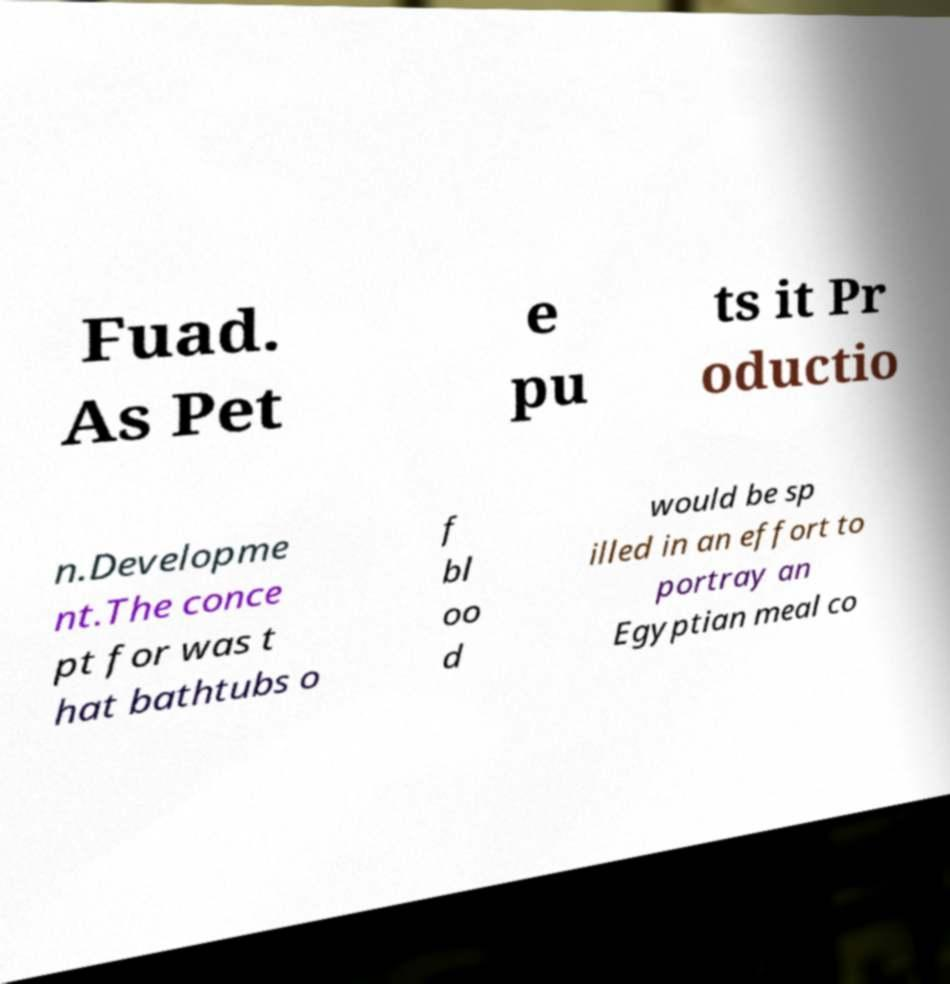Can you accurately transcribe the text from the provided image for me? Fuad. As Pet e pu ts it Pr oductio n.Developme nt.The conce pt for was t hat bathtubs o f bl oo d would be sp illed in an effort to portray an Egyptian meal co 